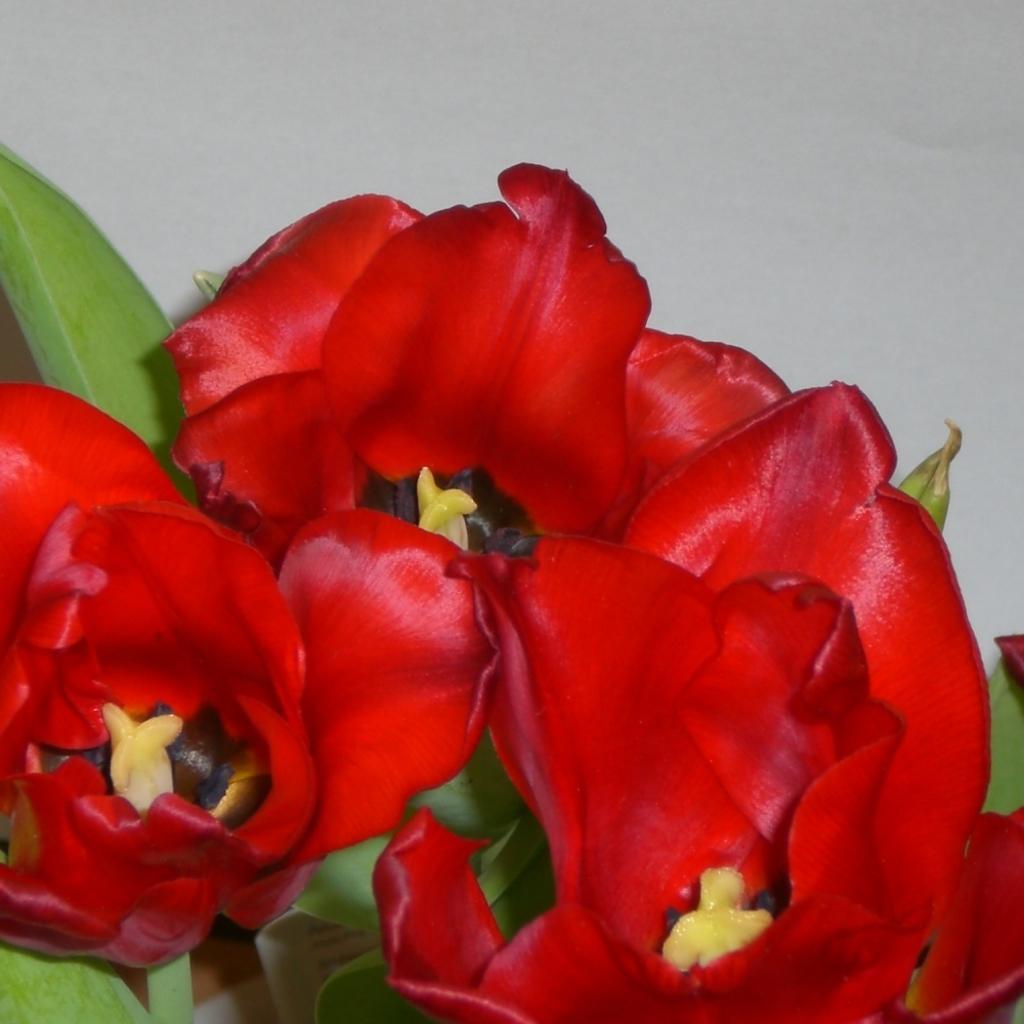Can you describe this image briefly? In this picture there are flowers, which are red in color in the center of the image. 